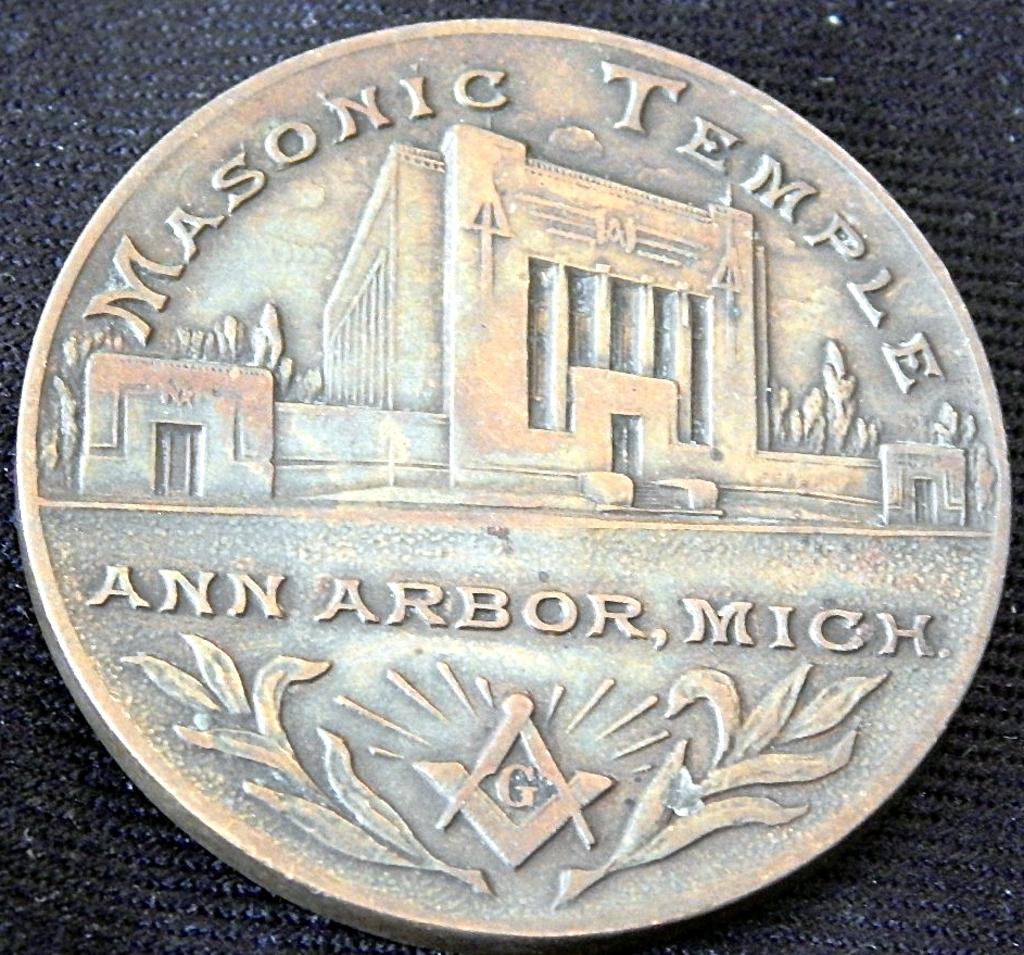<image>
Render a clear and concise summary of the photo. Masonic Temple written on the face of a silver color coin. 